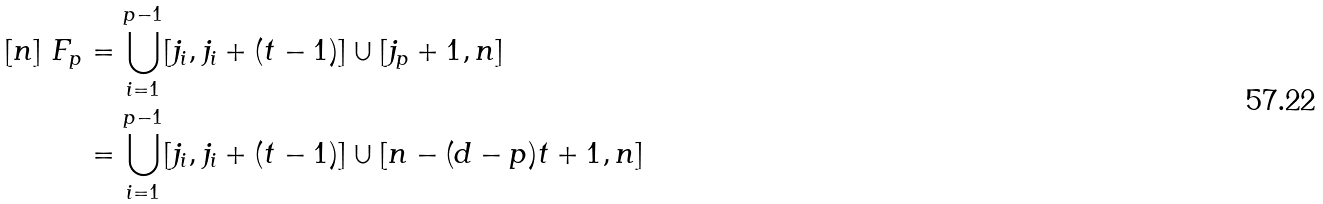Convert formula to latex. <formula><loc_0><loc_0><loc_500><loc_500>[ n ] \ F _ { p } & = \bigcup _ { i = 1 } ^ { p - 1 } [ j _ { i } , j _ { i } + ( t - 1 ) ] \cup [ j _ { p } + 1 , n ] \\ & = \bigcup _ { i = 1 } ^ { p - 1 } [ j _ { i } , j _ { i } + ( t - 1 ) ] \cup [ n - ( d - p ) t + 1 , n ]</formula> 